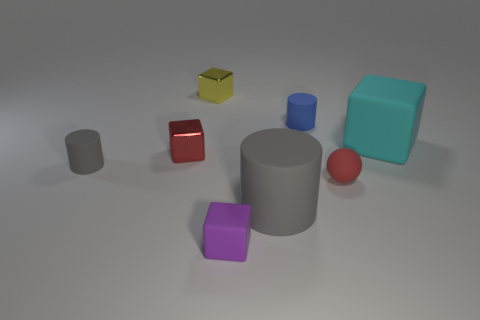Subtract all tiny cylinders. How many cylinders are left? 1 Add 1 shiny objects. How many objects exist? 9 Subtract 1 cylinders. How many cylinders are left? 2 Subtract all gray cylinders. How many cylinders are left? 1 Subtract all spheres. How many objects are left? 7 Subtract all green spheres. Subtract all purple cylinders. How many spheres are left? 1 Subtract all cyan cubes. How many gray cylinders are left? 2 Subtract all blue matte things. Subtract all purple matte blocks. How many objects are left? 6 Add 2 big gray things. How many big gray things are left? 3 Add 6 cylinders. How many cylinders exist? 9 